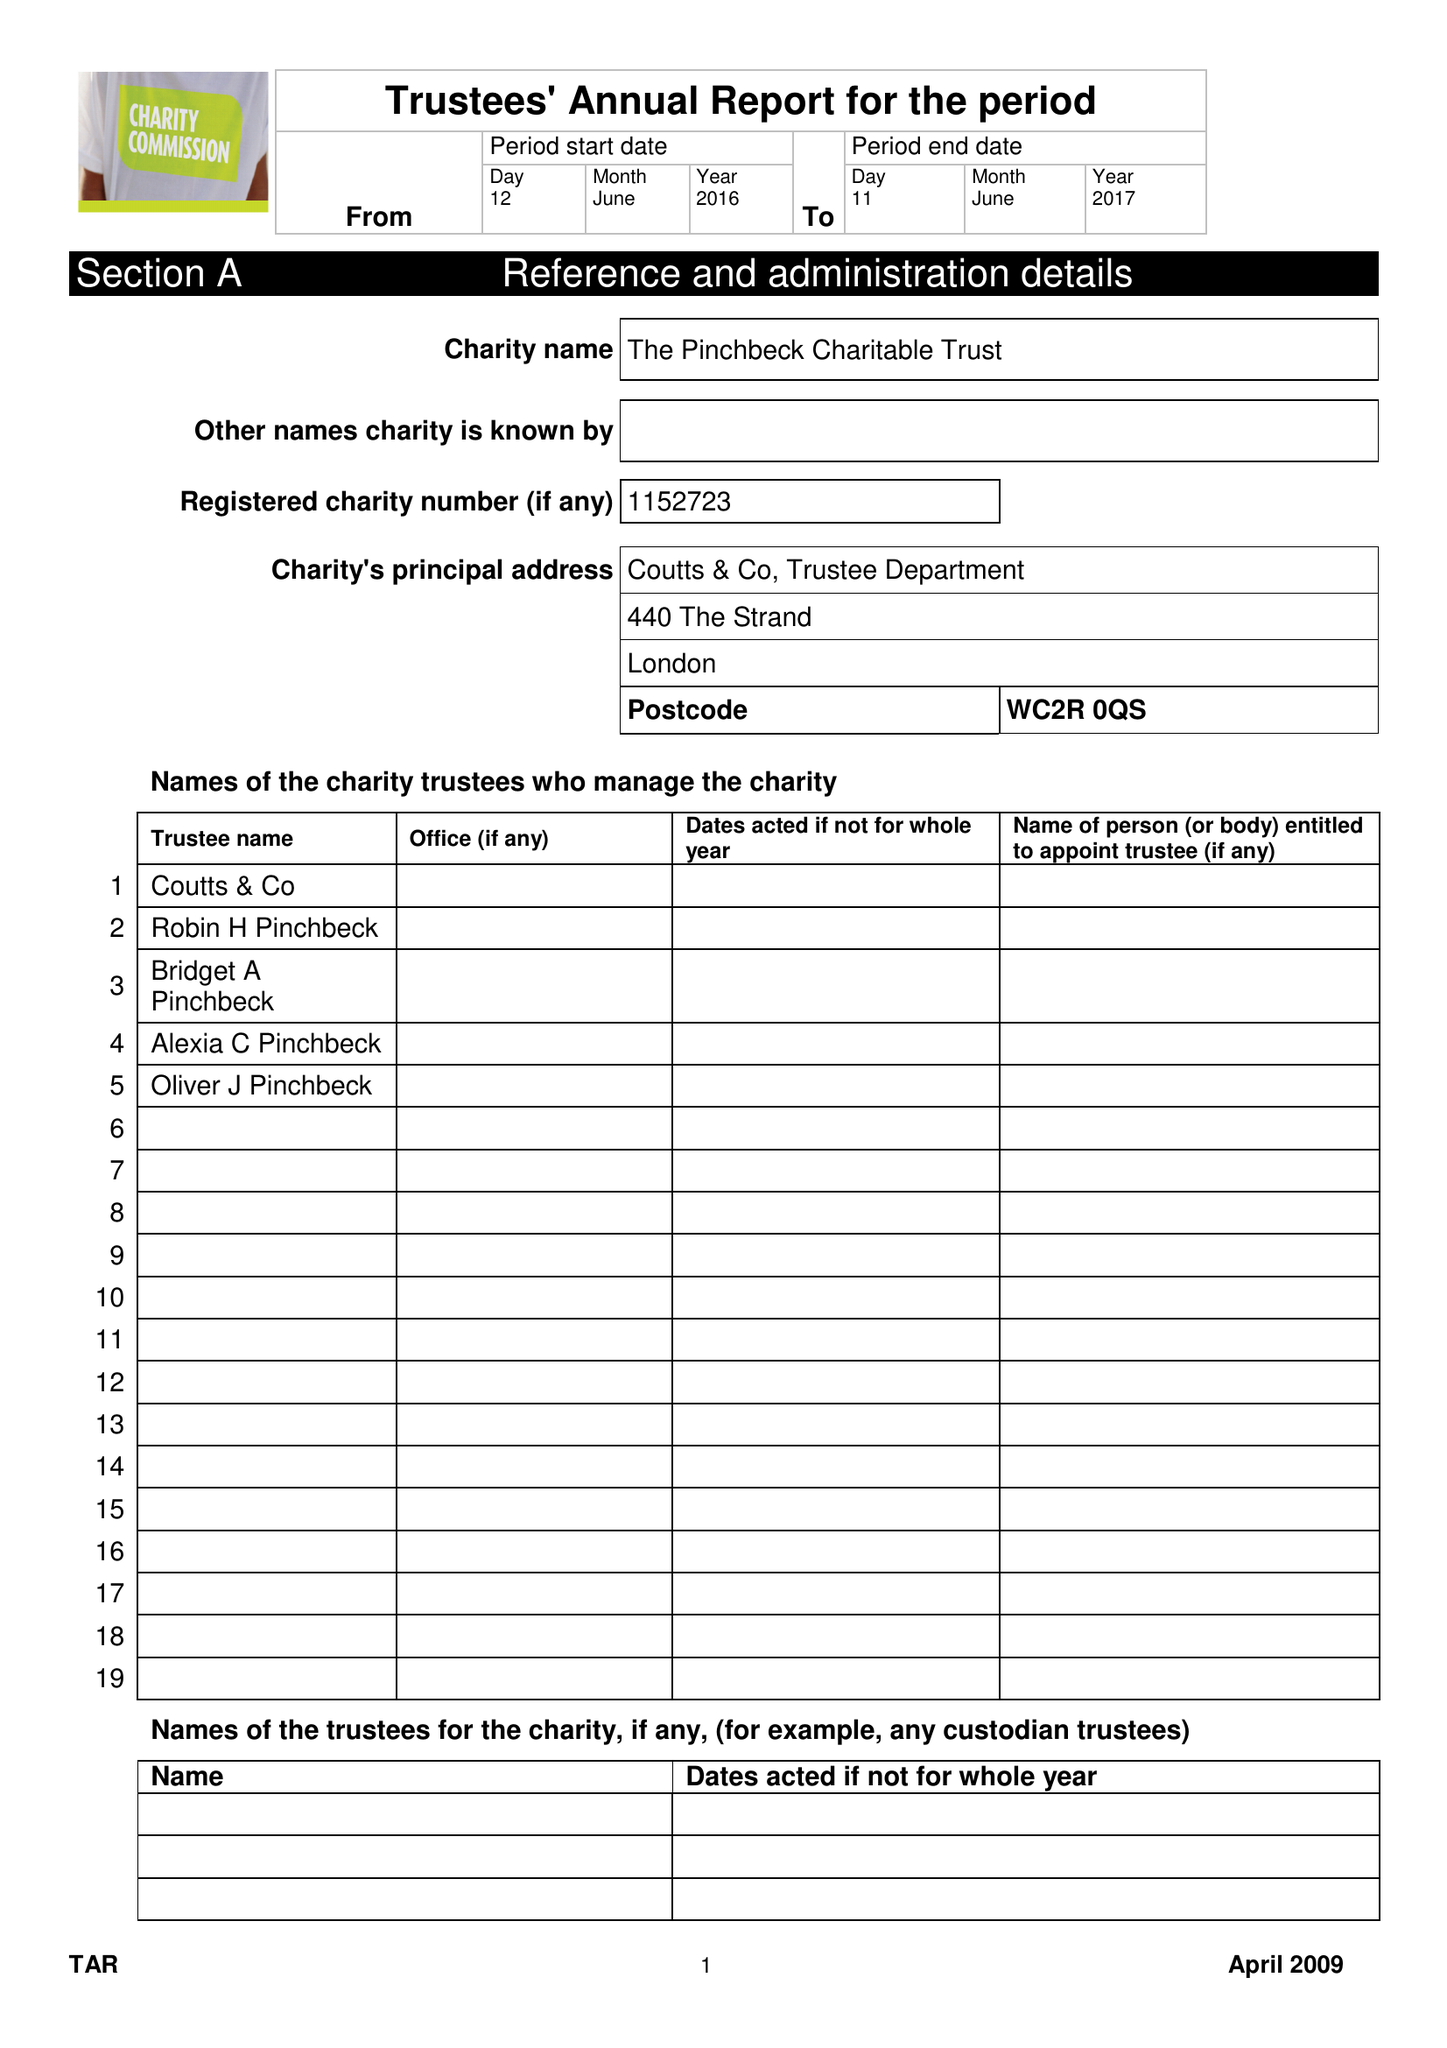What is the value for the charity_name?
Answer the question using a single word or phrase. The Pinchbeck Charitable Trust 